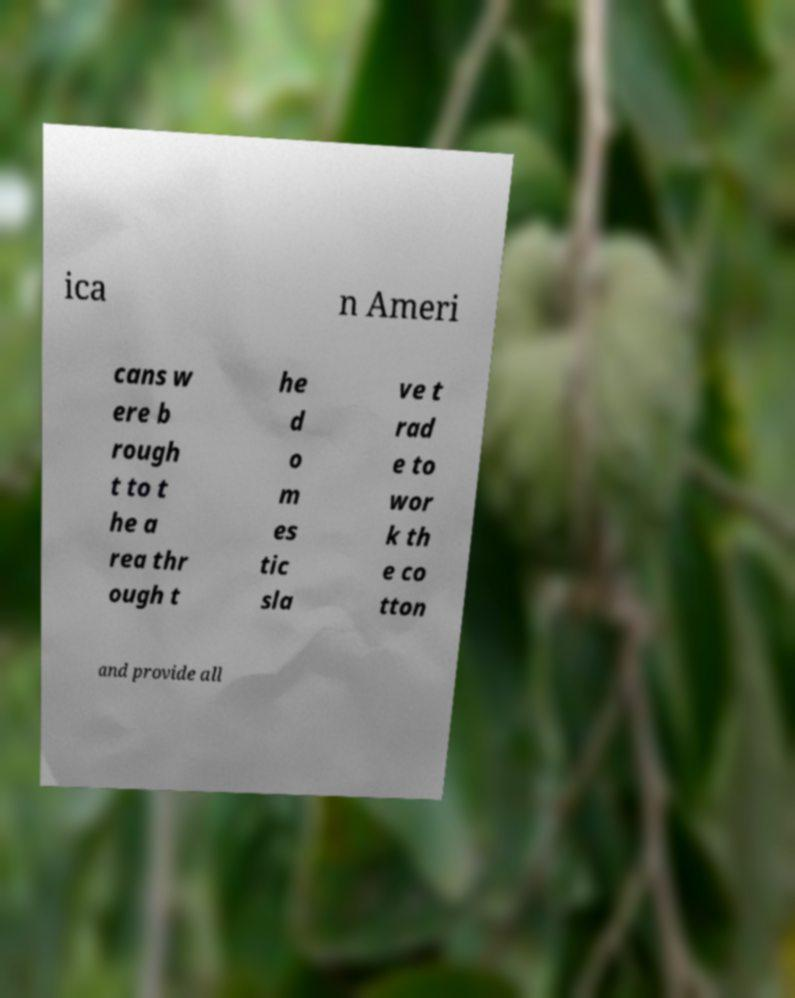Could you assist in decoding the text presented in this image and type it out clearly? ica n Ameri cans w ere b rough t to t he a rea thr ough t he d o m es tic sla ve t rad e to wor k th e co tton and provide all 